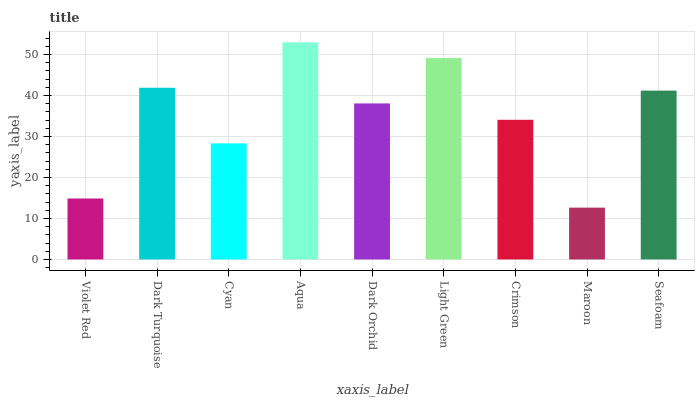Is Dark Turquoise the minimum?
Answer yes or no. No. Is Dark Turquoise the maximum?
Answer yes or no. No. Is Dark Turquoise greater than Violet Red?
Answer yes or no. Yes. Is Violet Red less than Dark Turquoise?
Answer yes or no. Yes. Is Violet Red greater than Dark Turquoise?
Answer yes or no. No. Is Dark Turquoise less than Violet Red?
Answer yes or no. No. Is Dark Orchid the high median?
Answer yes or no. Yes. Is Dark Orchid the low median?
Answer yes or no. Yes. Is Crimson the high median?
Answer yes or no. No. Is Maroon the low median?
Answer yes or no. No. 